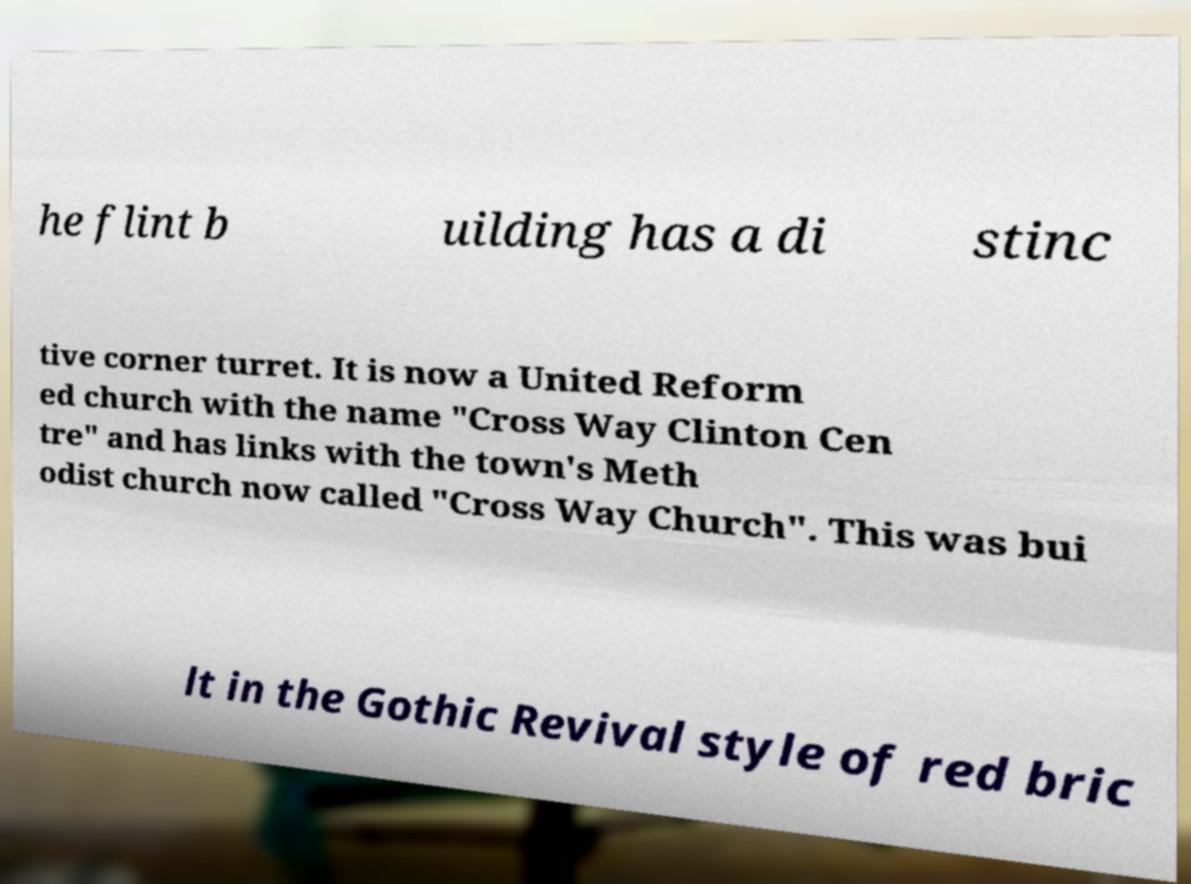Please identify and transcribe the text found in this image. he flint b uilding has a di stinc tive corner turret. It is now a United Reform ed church with the name "Cross Way Clinton Cen tre" and has links with the town's Meth odist church now called "Cross Way Church". This was bui lt in the Gothic Revival style of red bric 